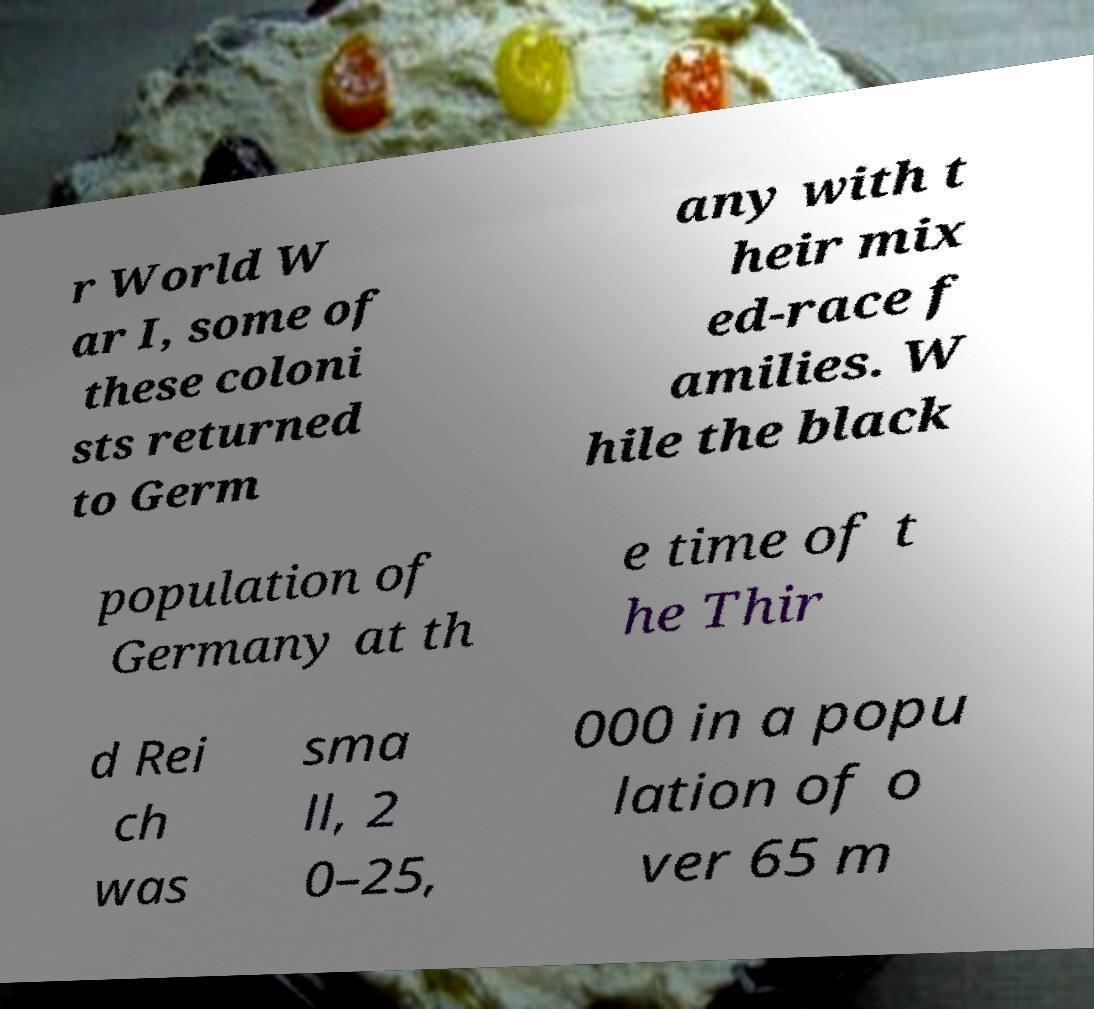Could you extract and type out the text from this image? r World W ar I, some of these coloni sts returned to Germ any with t heir mix ed-race f amilies. W hile the black population of Germany at th e time of t he Thir d Rei ch was sma ll, 2 0–25, 000 in a popu lation of o ver 65 m 